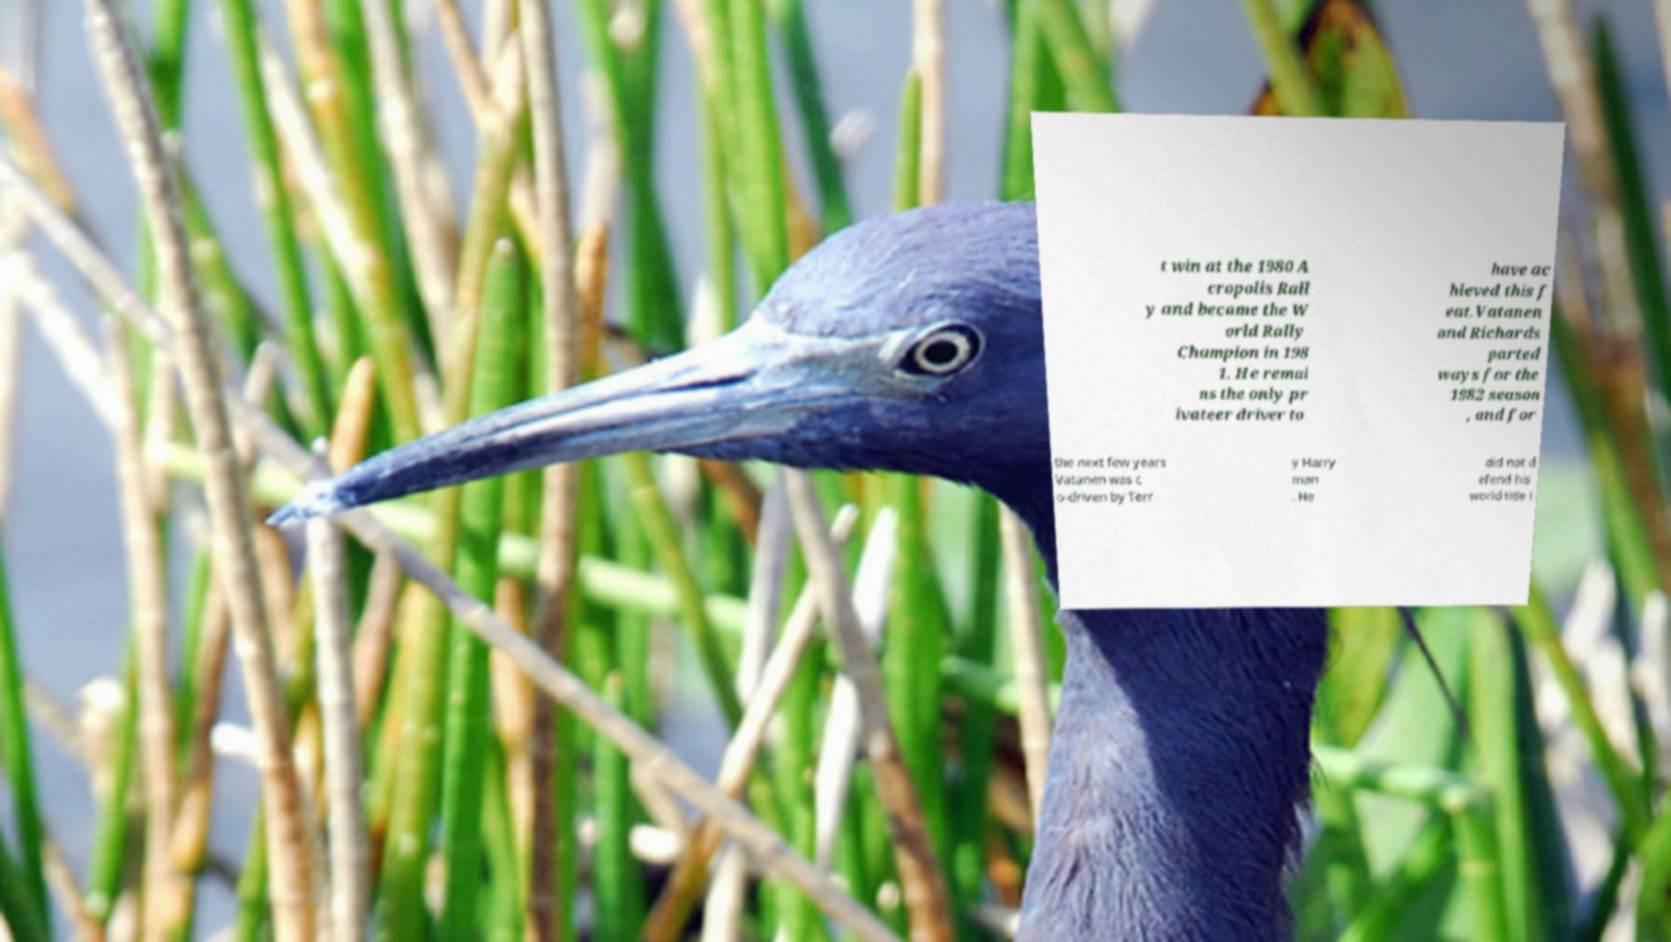Can you read and provide the text displayed in the image?This photo seems to have some interesting text. Can you extract and type it out for me? t win at the 1980 A cropolis Rall y and became the W orld Rally Champion in 198 1. He remai ns the only pr ivateer driver to have ac hieved this f eat.Vatanen and Richards parted ways for the 1982 season , and for the next few years Vatanen was c o-driven by Terr y Harry man . He did not d efend his world title i 